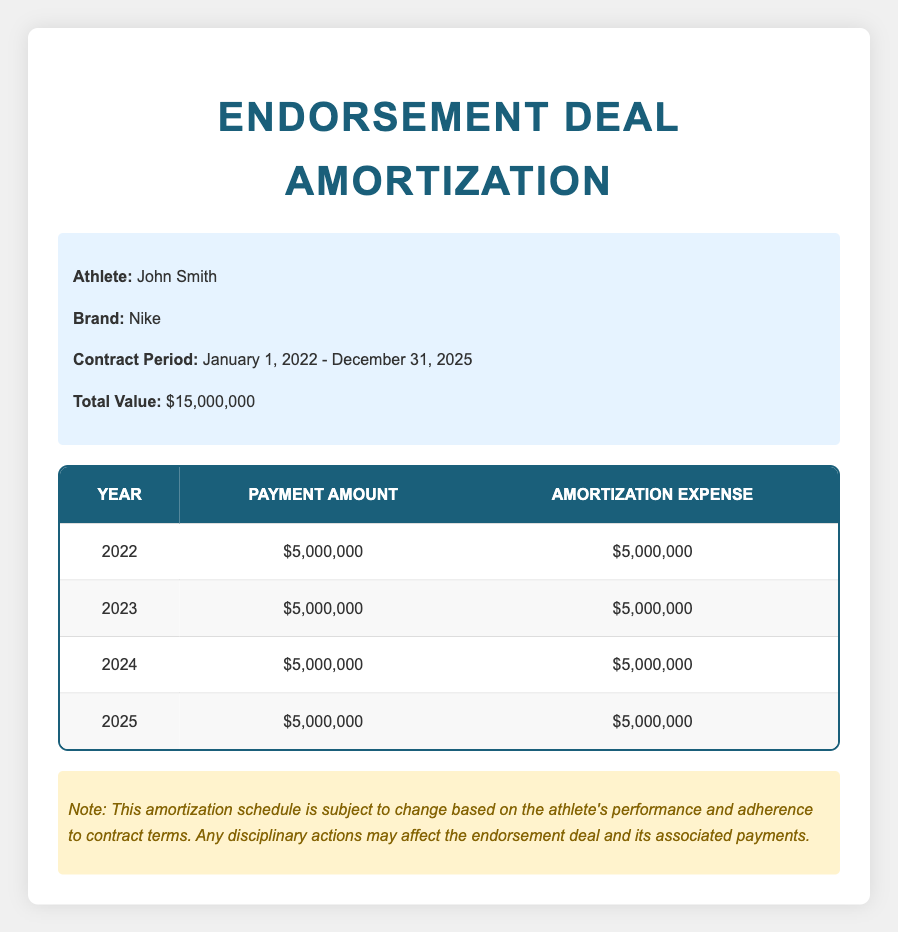What is the total value of the endorsement contract? The total value of the endorsement contract is explicitly stated in the information section of the table as 15,000,000.
Answer: 15,000,000 How much is the annual payment for the endorsement deal? Each year's payment amount is listed as 5,000,000 for all four years from 2022 to 2025.
Answer: 5,000,000 In which year did John Smith receive his first payment? The first payment listed in the table is for the year 2022, indicating that's when he received his first payment.
Answer: 2022 Is the amortization expense the same each year? Yes, the table indicates that the amortization expense is 5,000,000 for each year from 2022 to 2025, showing consistency.
Answer: Yes What is the total amortization expense over the four years? To find the total amortization expense, sum the yearly amortization amounts: 5,000,000 + 5,000,000 + 5,000,000 + 5,000,000 equals 20,000,000.
Answer: 20,000,000 If John Smith is disciplined and loses the endorsement deal in 2024, how much would he have received in payments up to that point? The payments for 2022 and 2023 would total 5,000,000 + 5,000,000 = 10,000,000. The payment for 2024 would not be counted since he would not receive it.
Answer: 10,000,000 What is the average yearly payment amount over the contract period? There are four payments of 5,000,000 made over four years. Summing them gives 20,000,000 and dividing by 4 results in an average payment amount of 5,000,000.
Answer: 5,000,000 How many years does the endorsement contract cover? The contract begins in 2022 and ends in 2025, covering four years in total.
Answer: 4 If John Smith received a payment in 2025, how many payments have he received by that year? Payments are made annually, and since payments were made in 2022, 2023, 2024, and 2025, he would have received a total of four payments by 2025.
Answer: 4 